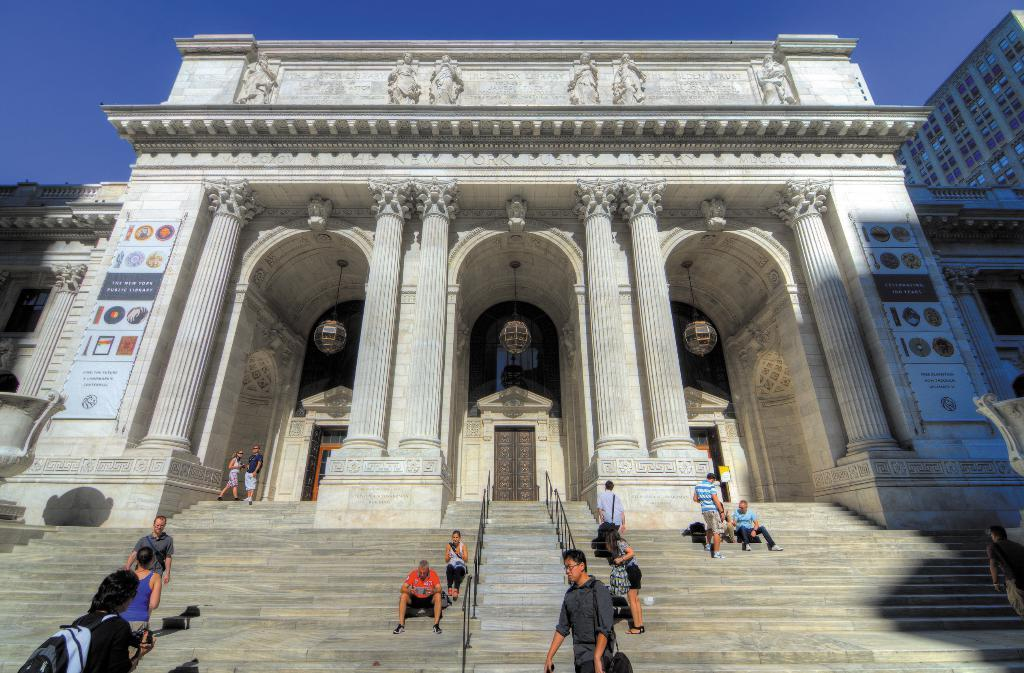How many buildings can be seen in the image? There are two buildings in the image. What is unique about one of the buildings? One of the buildings has two posts attached with pictures. Can you describe the people visible in the image? There are people visible in the image, but their specific actions or characteristics are not mentioned. What is visible at the top of the image? The sky is visible at the top of the image. What type of grape is being advertised on the building in the image? There is no grape or advertisement present in the image; it features two buildings with pictures on one of them. 